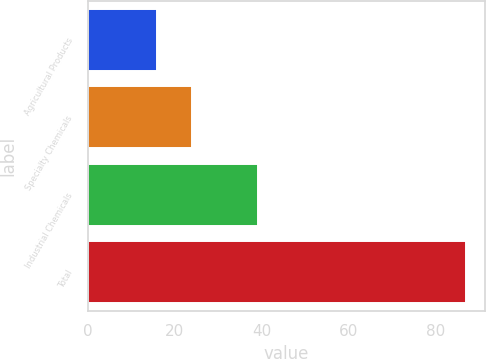Convert chart to OTSL. <chart><loc_0><loc_0><loc_500><loc_500><bar_chart><fcel>Agricultural Products<fcel>Specialty Chemicals<fcel>Industrial Chemicals<fcel>Total<nl><fcel>15.8<fcel>24<fcel>39.1<fcel>87<nl></chart> 